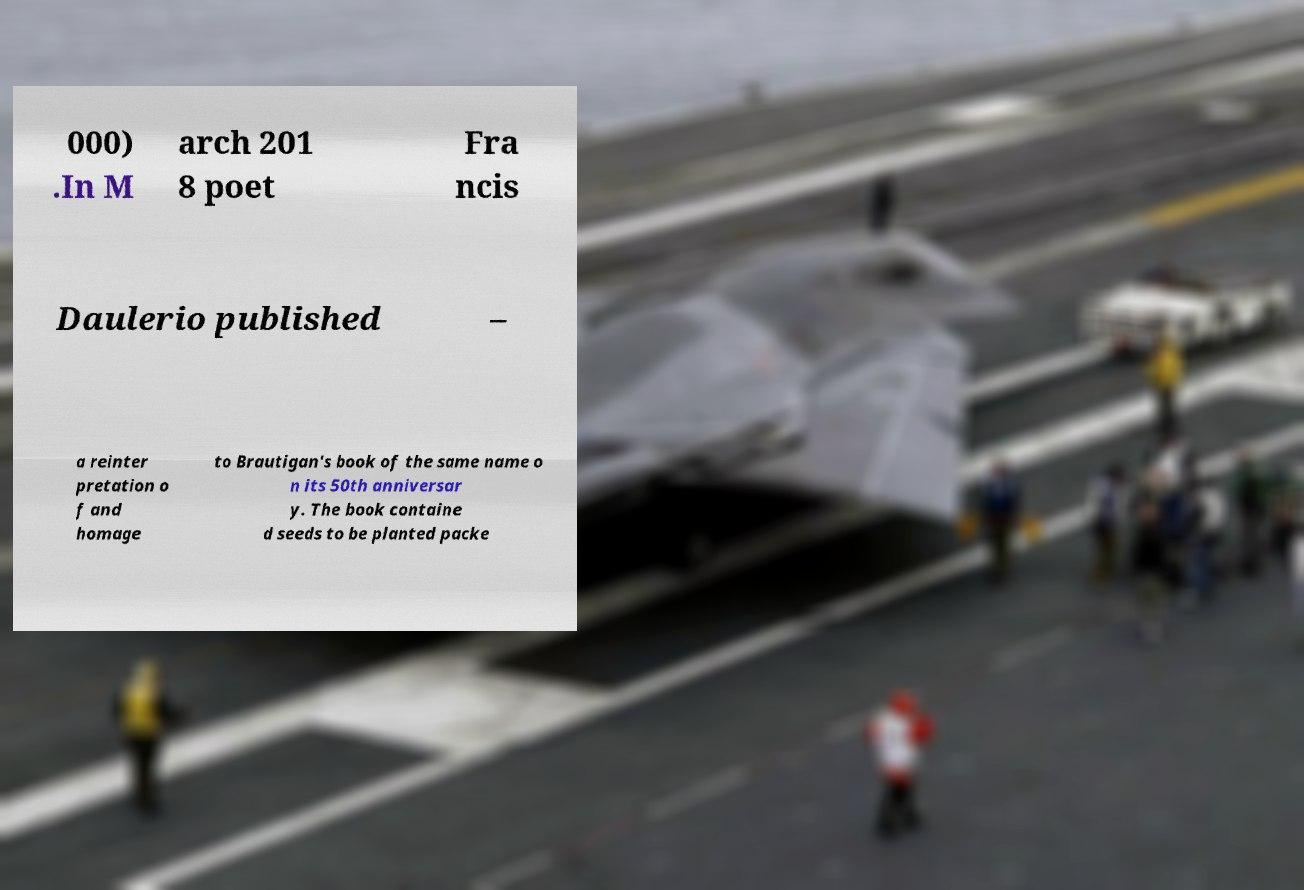What messages or text are displayed in this image? I need them in a readable, typed format. 000) .In M arch 201 8 poet Fra ncis Daulerio published – a reinter pretation o f and homage to Brautigan's book of the same name o n its 50th anniversar y. The book containe d seeds to be planted packe 